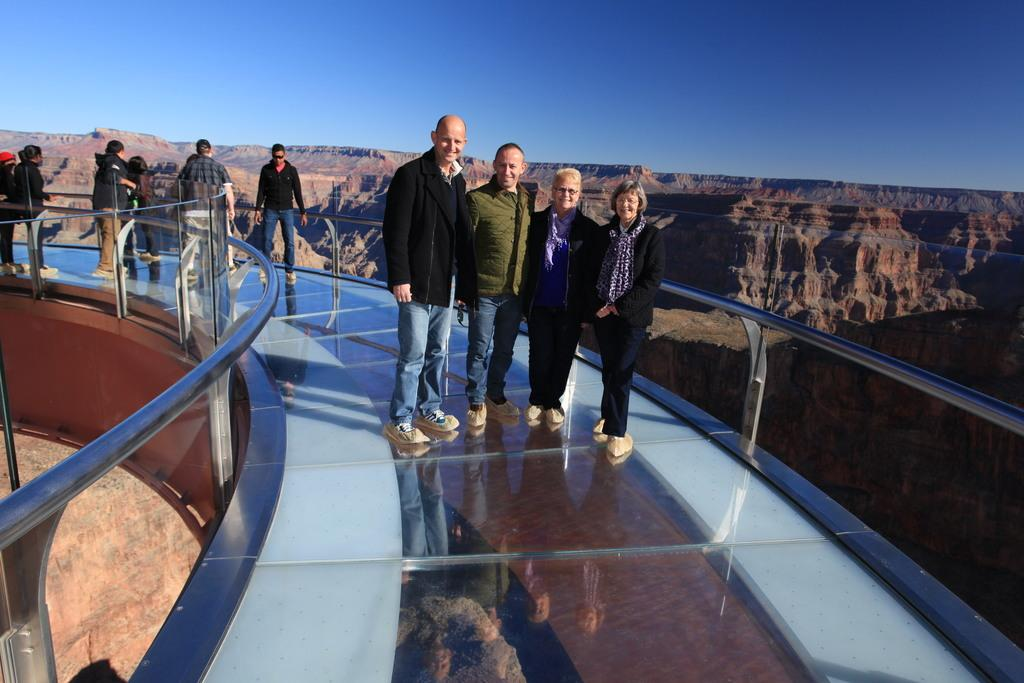What can be seen on the bridge in the image? There are people on the bridge in the image. What objects are present in the image besides the people on the bridge? There are poles and a rock hill visible in the image. What is visible in the background of the image? The sky is visible in the image. What type of advertisement can be seen on the rock hill in the image? There is no advertisement present on the rock hill in the image. How many groups of people are visible on the bridge in the image? The image does not provide information about the number of groups of people on the bridge, only that there are people present. 